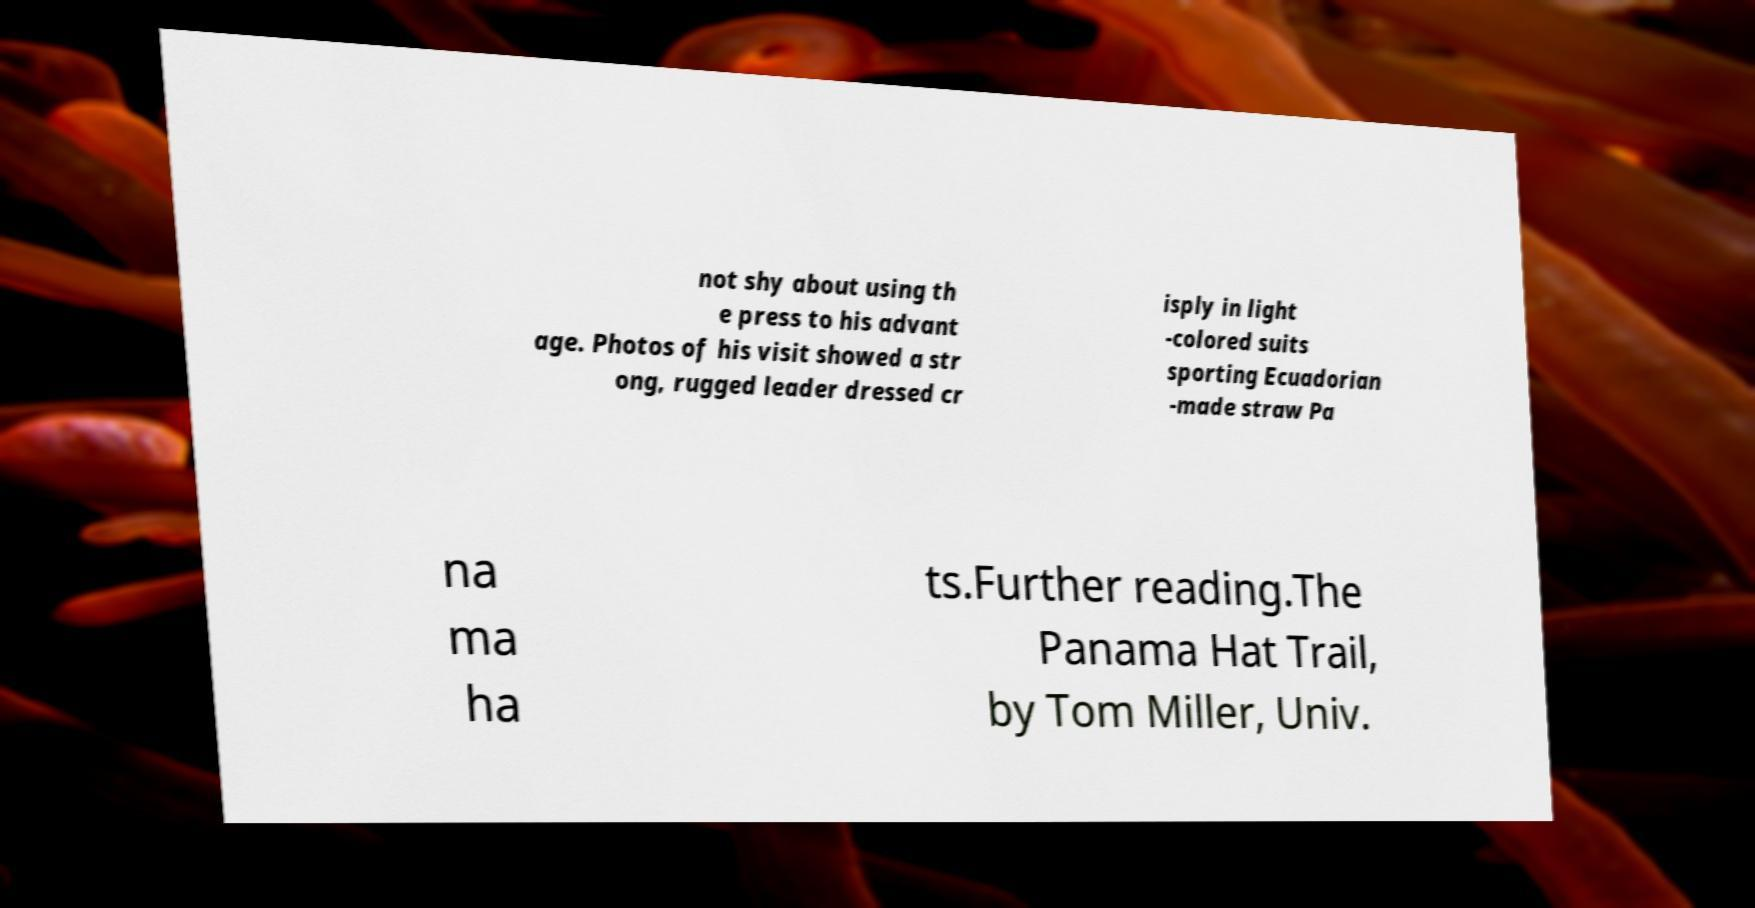For documentation purposes, I need the text within this image transcribed. Could you provide that? not shy about using th e press to his advant age. Photos of his visit showed a str ong, rugged leader dressed cr isply in light -colored suits sporting Ecuadorian -made straw Pa na ma ha ts.Further reading.The Panama Hat Trail, by Tom Miller, Univ. 